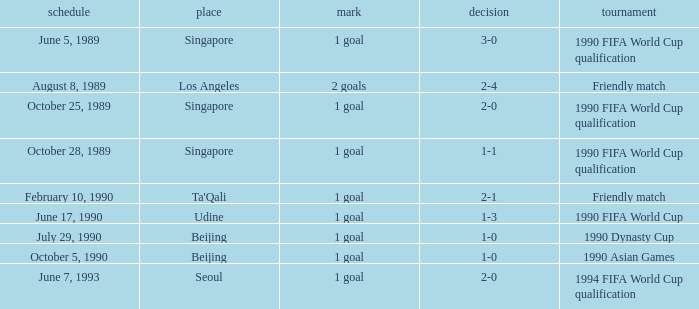What is the score of the match on July 29, 1990? 1 goal. 